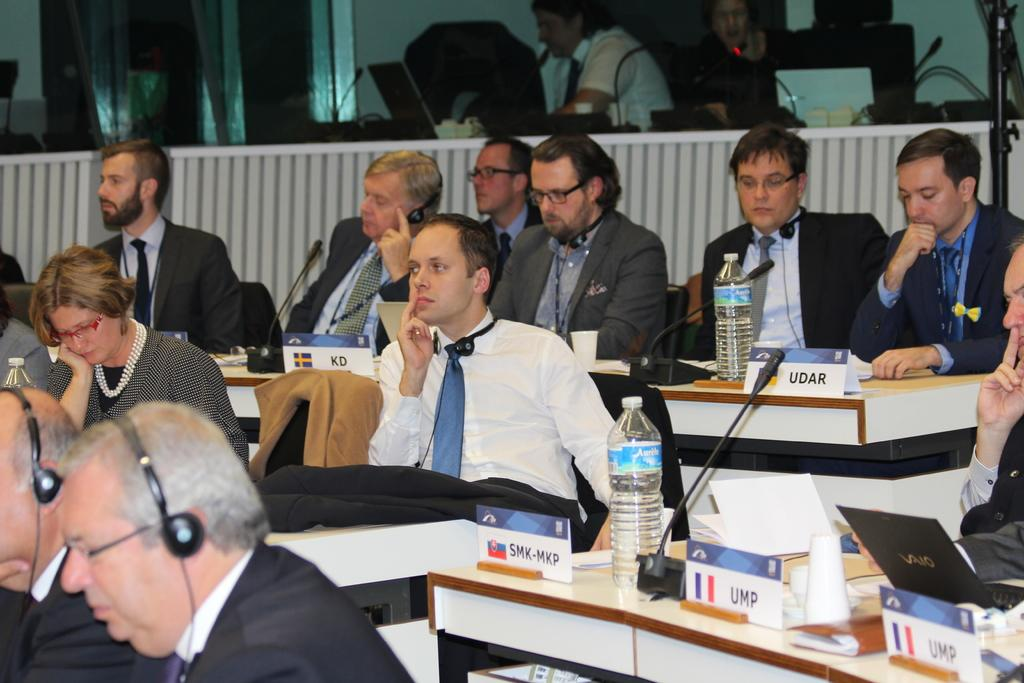What is the man in the middle of the image doing? The man is sitting in the middle of the image. What is the man wearing in the image? The man is wearing a white shirt and a tie. What can be seen on the right side of the image? There is a water bottle on a table in the right side of the image. How many other men are sitting in the image? There are other men sitting on chairs in the image. What color is the sock on the wall in the image? There is no sock on the wall in the image. How does the power of the man's tie affect the other men in the image? There is no mention of the power of the man's tie or its effect on the other men in the image. 